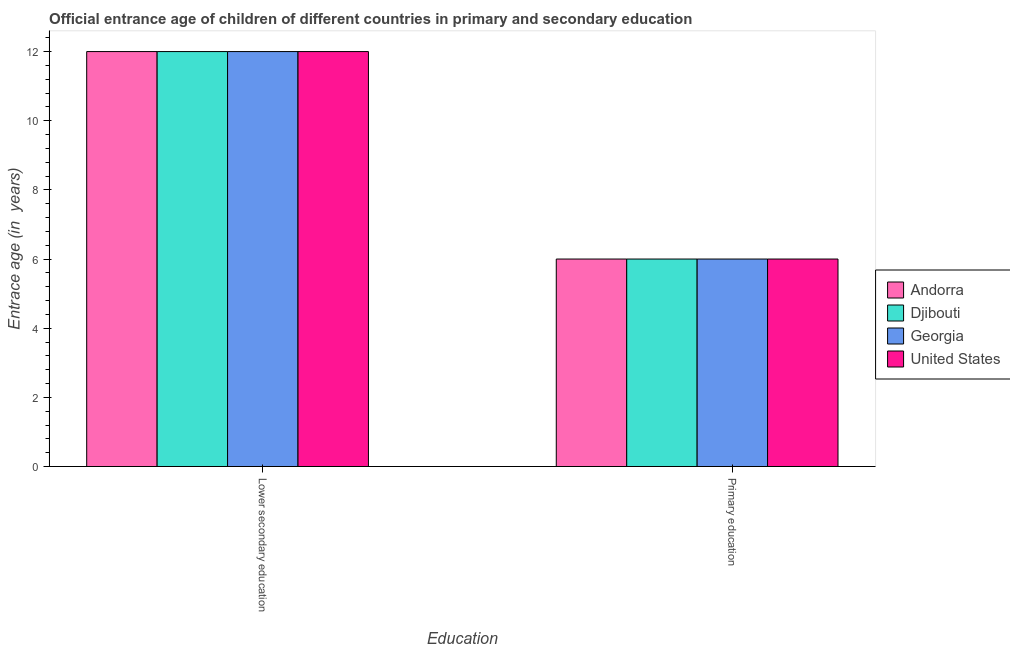How many different coloured bars are there?
Ensure brevity in your answer.  4. Are the number of bars per tick equal to the number of legend labels?
Keep it short and to the point. Yes. Are the number of bars on each tick of the X-axis equal?
Offer a terse response. Yes. What is the label of the 2nd group of bars from the left?
Offer a very short reply. Primary education. What is the entrance age of chiildren in primary education in Djibouti?
Give a very brief answer. 6. Across all countries, what is the maximum entrance age of children in lower secondary education?
Your answer should be very brief. 12. Across all countries, what is the minimum entrance age of chiildren in primary education?
Make the answer very short. 6. In which country was the entrance age of chiildren in primary education maximum?
Keep it short and to the point. Andorra. In which country was the entrance age of chiildren in primary education minimum?
Ensure brevity in your answer.  Andorra. What is the total entrance age of chiildren in primary education in the graph?
Offer a terse response. 24. What is the difference between the entrance age of chiildren in primary education in Georgia and the entrance age of children in lower secondary education in United States?
Make the answer very short. -6. What is the difference between the entrance age of children in lower secondary education and entrance age of chiildren in primary education in Georgia?
Make the answer very short. 6. In how many countries, is the entrance age of chiildren in primary education greater than 4.4 years?
Offer a terse response. 4. What does the 1st bar from the left in Lower secondary education represents?
Your response must be concise. Andorra. What does the 4th bar from the right in Primary education represents?
Ensure brevity in your answer.  Andorra. What is the difference between two consecutive major ticks on the Y-axis?
Ensure brevity in your answer.  2. Are the values on the major ticks of Y-axis written in scientific E-notation?
Your response must be concise. No. Does the graph contain any zero values?
Your answer should be compact. No. Where does the legend appear in the graph?
Ensure brevity in your answer.  Center right. How many legend labels are there?
Your response must be concise. 4. How are the legend labels stacked?
Offer a terse response. Vertical. What is the title of the graph?
Your answer should be compact. Official entrance age of children of different countries in primary and secondary education. What is the label or title of the X-axis?
Your response must be concise. Education. What is the label or title of the Y-axis?
Give a very brief answer. Entrace age (in  years). What is the Entrace age (in  years) in Djibouti in Lower secondary education?
Provide a succinct answer. 12. What is the Entrace age (in  years) of United States in Lower secondary education?
Make the answer very short. 12. What is the Entrace age (in  years) of United States in Primary education?
Keep it short and to the point. 6. Across all Education, what is the maximum Entrace age (in  years) in Andorra?
Make the answer very short. 12. Across all Education, what is the maximum Entrace age (in  years) of Djibouti?
Keep it short and to the point. 12. Across all Education, what is the maximum Entrace age (in  years) of Georgia?
Your answer should be compact. 12. Across all Education, what is the maximum Entrace age (in  years) of United States?
Your answer should be very brief. 12. Across all Education, what is the minimum Entrace age (in  years) of Georgia?
Offer a terse response. 6. What is the total Entrace age (in  years) in Andorra in the graph?
Offer a very short reply. 18. What is the total Entrace age (in  years) of Djibouti in the graph?
Offer a very short reply. 18. What is the total Entrace age (in  years) of Georgia in the graph?
Give a very brief answer. 18. What is the difference between the Entrace age (in  years) of Andorra in Lower secondary education and that in Primary education?
Make the answer very short. 6. What is the difference between the Entrace age (in  years) of Georgia in Lower secondary education and that in Primary education?
Your response must be concise. 6. What is the difference between the Entrace age (in  years) of United States in Lower secondary education and that in Primary education?
Your response must be concise. 6. What is the difference between the Entrace age (in  years) of Andorra in Lower secondary education and the Entrace age (in  years) of Georgia in Primary education?
Offer a very short reply. 6. What is the difference between the Entrace age (in  years) in Andorra in Lower secondary education and the Entrace age (in  years) in United States in Primary education?
Your answer should be compact. 6. What is the difference between the Entrace age (in  years) in Georgia in Lower secondary education and the Entrace age (in  years) in United States in Primary education?
Provide a short and direct response. 6. What is the average Entrace age (in  years) in Djibouti per Education?
Keep it short and to the point. 9. What is the average Entrace age (in  years) of United States per Education?
Provide a short and direct response. 9. What is the difference between the Entrace age (in  years) in Andorra and Entrace age (in  years) in United States in Lower secondary education?
Keep it short and to the point. 0. What is the difference between the Entrace age (in  years) of Djibouti and Entrace age (in  years) of Georgia in Lower secondary education?
Your answer should be very brief. 0. What is the difference between the Entrace age (in  years) in Andorra and Entrace age (in  years) in United States in Primary education?
Offer a terse response. 0. What is the difference between the Entrace age (in  years) in Georgia and Entrace age (in  years) in United States in Primary education?
Ensure brevity in your answer.  0. What is the ratio of the Entrace age (in  years) in Djibouti in Lower secondary education to that in Primary education?
Your response must be concise. 2. What is the difference between the highest and the second highest Entrace age (in  years) of Georgia?
Your response must be concise. 6. What is the difference between the highest and the lowest Entrace age (in  years) in Andorra?
Give a very brief answer. 6. 